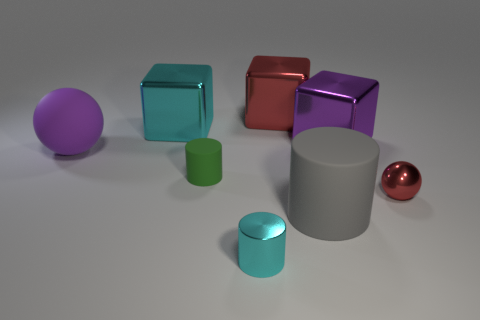Is there anything else of the same color as the tiny matte cylinder?
Provide a short and direct response. No. Is the shape of the big red object the same as the purple matte thing?
Your answer should be very brief. No. How big is the rubber cylinder that is on the right side of the small cylinder behind the red thing in front of the purple metal block?
Make the answer very short. Large. What number of other things are there of the same material as the large gray cylinder
Your response must be concise. 2. The big metallic block that is to the left of the cyan cylinder is what color?
Provide a short and direct response. Cyan. There is a red object that is behind the large shiny object that is on the left side of the cyan metal object that is right of the tiny green cylinder; what is its material?
Offer a terse response. Metal. Are there any other small objects that have the same shape as the tiny rubber object?
Your response must be concise. Yes. The red shiny object that is the same size as the cyan cube is what shape?
Ensure brevity in your answer.  Cube. How many shiny objects are both on the left side of the big purple metallic object and behind the small red thing?
Give a very brief answer. 2. Are there fewer tiny cylinders right of the small cyan metallic object than large red metal blocks?
Your response must be concise. Yes. 